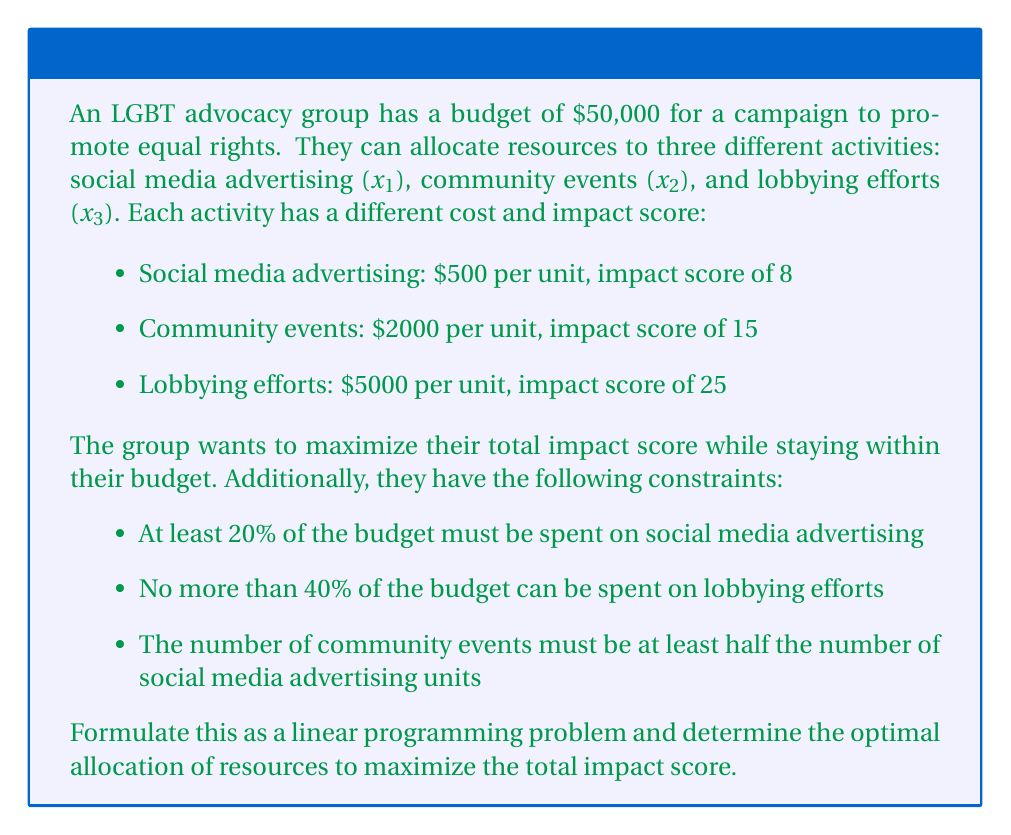Teach me how to tackle this problem. To solve this problem, we'll follow these steps:

1. Define the variables:
   $x_1$ = number of social media advertising units
   $x_2$ = number of community events
   $x_3$ = number of lobbying effort units

2. Formulate the objective function:
   Maximize $Z = 8x_1 + 15x_2 + 25x_3$

3. Identify the constraints:
   a) Budget constraint: $500x_1 + 2000x_2 + 5000x_3 \leq 50000$
   b) Social media advertising minimum: $500x_1 \geq 0.2 \times 50000 = 10000$
   c) Lobbying efforts maximum: $5000x_3 \leq 0.4 \times 50000 = 20000$
   d) Community events relation: $x_2 \geq 0.5x_1$
   e) Non-negativity: $x_1, x_2, x_3 \geq 0$

4. Simplify the constraints:
   a) $x_1 + 4x_2 + 10x_3 \leq 100$
   b) $x_1 \geq 20$
   c) $x_3 \leq 4$
   d) $x_2 - 0.5x_1 \geq 0$
   e) $x_1, x_2, x_3 \geq 0$

5. Solve using the simplex method or linear programming software.

The optimal solution is:
$x_1 = 20$ (social media advertising units)
$x_2 = 10$ (community events)
$x_3 = 4$ (lobbying effort units)

6. Calculate the maximum impact score:
   $Z = 8(20) + 15(10) + 25(4) = 160 + 150 + 100 = 410$

7. Verify the constraints:
   a) $20 + 4(10) + 10(4) = 20 + 40 + 40 = 100 \leq 100$ (Budget satisfied)
   b) $20 \geq 20$ (Social media minimum satisfied)
   c) $4 \leq 4$ (Lobbying maximum satisfied)
   d) $10 \geq 0.5(20) = 10$ (Community events relation satisfied)
   e) All variables are non-negative
Answer: The optimal allocation of resources is:
- 20 units of social media advertising ($10,000)
- 10 community events ($20,000)
- 4 units of lobbying efforts ($20,000)

This allocation yields a maximum impact score of 410. 